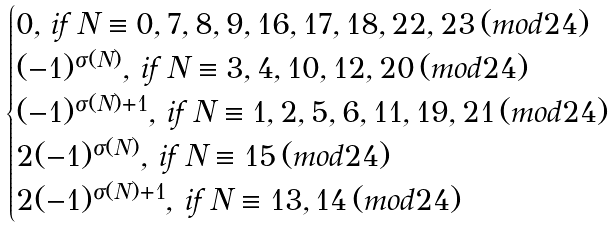Convert formula to latex. <formula><loc_0><loc_0><loc_500><loc_500>\begin{cases} 0 , \, i f \, N \equiv 0 , 7 , 8 , 9 , 1 6 , 1 7 , 1 8 , 2 2 , 2 3 \, ( m o d 2 4 ) \\ ( - 1 ) ^ { \sigma ( N ) } , \, i f \, N \equiv 3 , 4 , 1 0 , 1 2 , 2 0 \, ( m o d 2 4 ) \\ ( - 1 ) ^ { \sigma ( N ) + 1 } , \, i f \, N \equiv 1 , 2 , 5 , 6 , 1 1 , 1 9 , 2 1 \, ( m o d 2 4 ) \\ 2 ( - 1 ) ^ { \sigma ( N ) } , \, i f \, N \equiv 1 5 \, ( m o d 2 4 ) \\ 2 ( - 1 ) ^ { \sigma ( N ) + 1 } , \, i f \, N \equiv 1 3 , 1 4 \, ( m o d 2 4 ) \end{cases}</formula> 